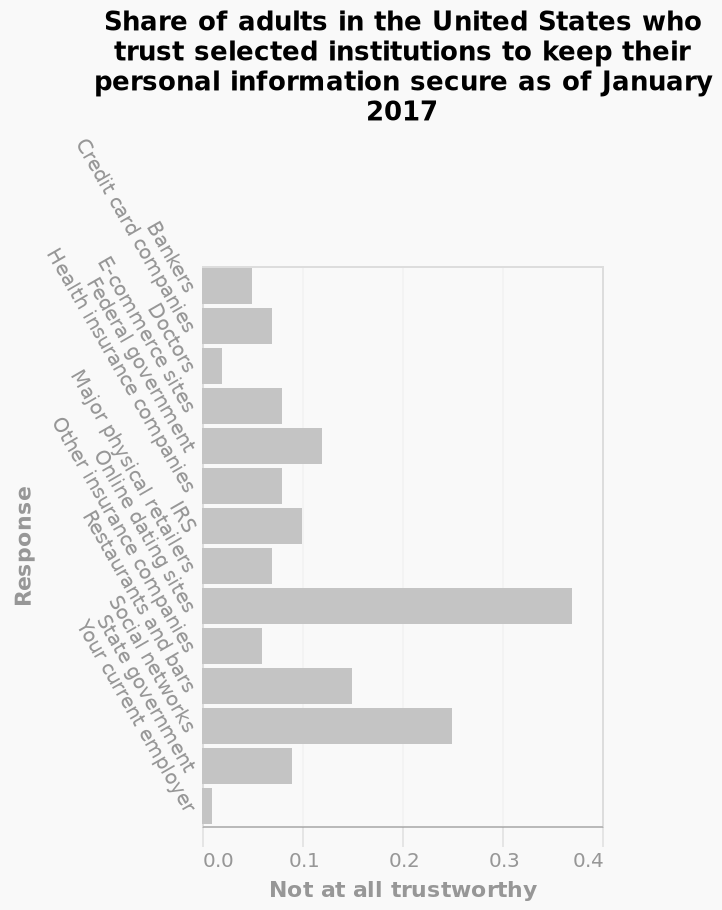<image>
Are people more suspicious of online dating sites or social networks? People find online dating sites more untrustworthy than social sites. What does the bar graph depict?  The bar graph depicts the share of adults in the United States who trust selected institutions to keep their personal information secure as of January 2017. 